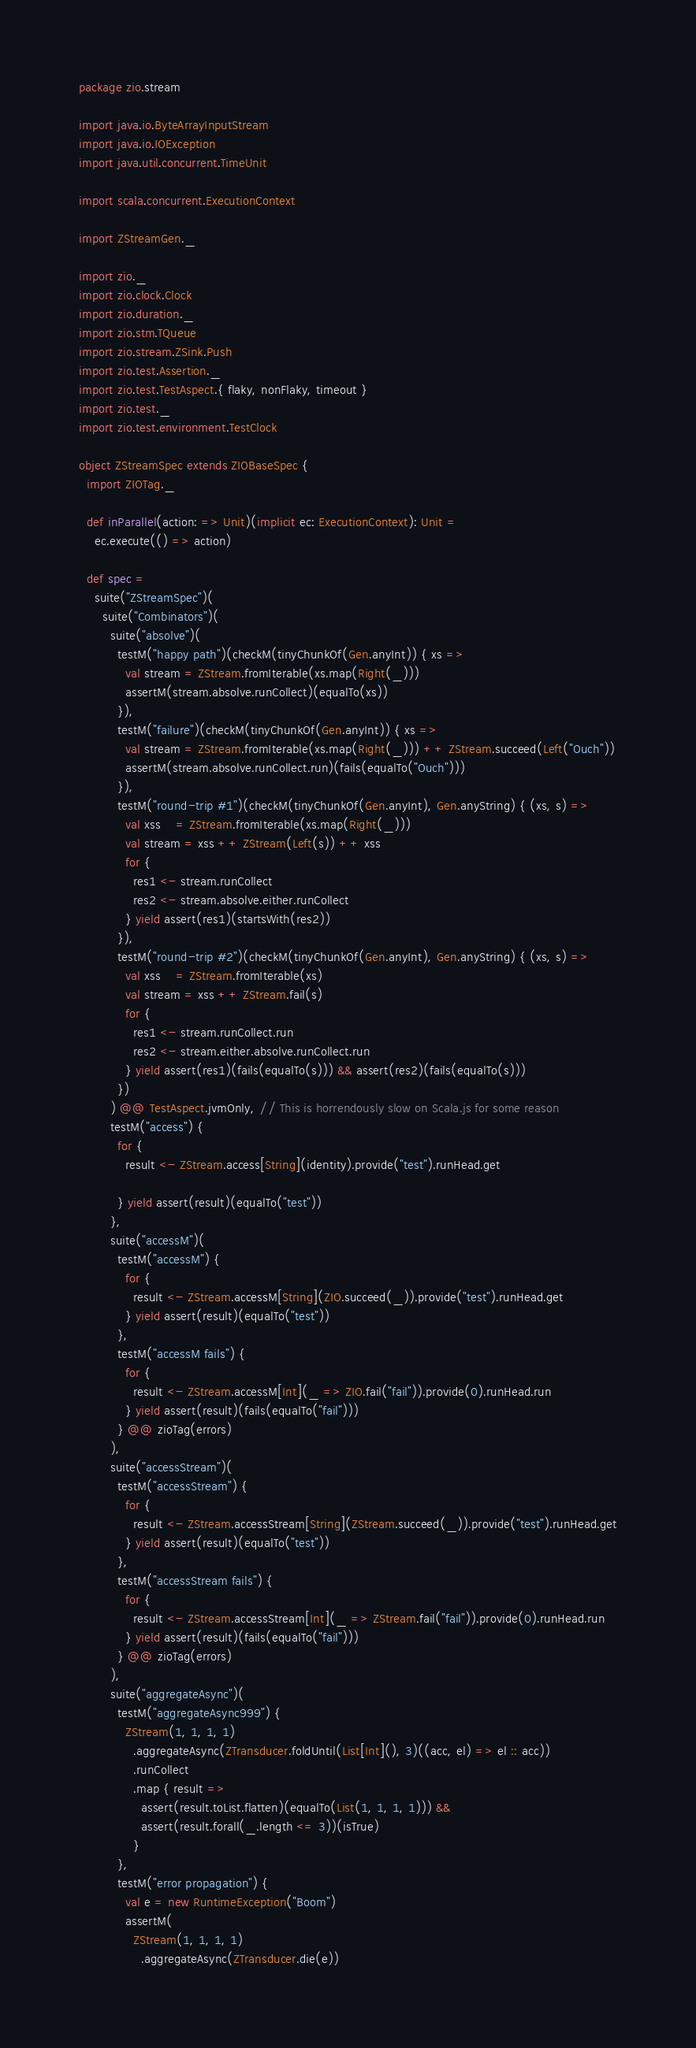<code> <loc_0><loc_0><loc_500><loc_500><_Scala_>package zio.stream

import java.io.ByteArrayInputStream
import java.io.IOException
import java.util.concurrent.TimeUnit

import scala.concurrent.ExecutionContext

import ZStreamGen._

import zio._
import zio.clock.Clock
import zio.duration._
import zio.stm.TQueue
import zio.stream.ZSink.Push
import zio.test.Assertion._
import zio.test.TestAspect.{ flaky, nonFlaky, timeout }
import zio.test._
import zio.test.environment.TestClock

object ZStreamSpec extends ZIOBaseSpec {
  import ZIOTag._

  def inParallel(action: => Unit)(implicit ec: ExecutionContext): Unit =
    ec.execute(() => action)

  def spec =
    suite("ZStreamSpec")(
      suite("Combinators")(
        suite("absolve")(
          testM("happy path")(checkM(tinyChunkOf(Gen.anyInt)) { xs =>
            val stream = ZStream.fromIterable(xs.map(Right(_)))
            assertM(stream.absolve.runCollect)(equalTo(xs))
          }),
          testM("failure")(checkM(tinyChunkOf(Gen.anyInt)) { xs =>
            val stream = ZStream.fromIterable(xs.map(Right(_))) ++ ZStream.succeed(Left("Ouch"))
            assertM(stream.absolve.runCollect.run)(fails(equalTo("Ouch")))
          }),
          testM("round-trip #1")(checkM(tinyChunkOf(Gen.anyInt), Gen.anyString) { (xs, s) =>
            val xss    = ZStream.fromIterable(xs.map(Right(_)))
            val stream = xss ++ ZStream(Left(s)) ++ xss
            for {
              res1 <- stream.runCollect
              res2 <- stream.absolve.either.runCollect
            } yield assert(res1)(startsWith(res2))
          }),
          testM("round-trip #2")(checkM(tinyChunkOf(Gen.anyInt), Gen.anyString) { (xs, s) =>
            val xss    = ZStream.fromIterable(xs)
            val stream = xss ++ ZStream.fail(s)
            for {
              res1 <- stream.runCollect.run
              res2 <- stream.either.absolve.runCollect.run
            } yield assert(res1)(fails(equalTo(s))) && assert(res2)(fails(equalTo(s)))
          })
        ) @@ TestAspect.jvmOnly, // This is horrendously slow on Scala.js for some reason
        testM("access") {
          for {
            result <- ZStream.access[String](identity).provide("test").runHead.get

          } yield assert(result)(equalTo("test"))
        },
        suite("accessM")(
          testM("accessM") {
            for {
              result <- ZStream.accessM[String](ZIO.succeed(_)).provide("test").runHead.get
            } yield assert(result)(equalTo("test"))
          },
          testM("accessM fails") {
            for {
              result <- ZStream.accessM[Int](_ => ZIO.fail("fail")).provide(0).runHead.run
            } yield assert(result)(fails(equalTo("fail")))
          } @@ zioTag(errors)
        ),
        suite("accessStream")(
          testM("accessStream") {
            for {
              result <- ZStream.accessStream[String](ZStream.succeed(_)).provide("test").runHead.get
            } yield assert(result)(equalTo("test"))
          },
          testM("accessStream fails") {
            for {
              result <- ZStream.accessStream[Int](_ => ZStream.fail("fail")).provide(0).runHead.run
            } yield assert(result)(fails(equalTo("fail")))
          } @@ zioTag(errors)
        ),
        suite("aggregateAsync")(
          testM("aggregateAsync999") {
            ZStream(1, 1, 1, 1)
              .aggregateAsync(ZTransducer.foldUntil(List[Int](), 3)((acc, el) => el :: acc))
              .runCollect
              .map { result =>
                assert(result.toList.flatten)(equalTo(List(1, 1, 1, 1))) &&
                assert(result.forall(_.length <= 3))(isTrue)
              }
          },
          testM("error propagation") {
            val e = new RuntimeException("Boom")
            assertM(
              ZStream(1, 1, 1, 1)
                .aggregateAsync(ZTransducer.die(e))</code> 